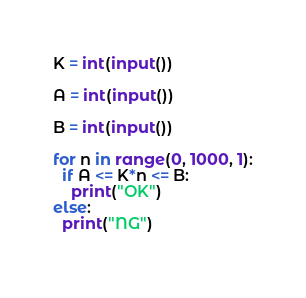Convert code to text. <code><loc_0><loc_0><loc_500><loc_500><_Python_>K = int(input())

A = int(input())

B = int(input())

for n in range(0, 1000, 1):
  if A <= K*n <= B:
    print("OK")
else:
  print("NG")
    

</code> 